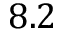<formula> <loc_0><loc_0><loc_500><loc_500>8 . 2</formula> 